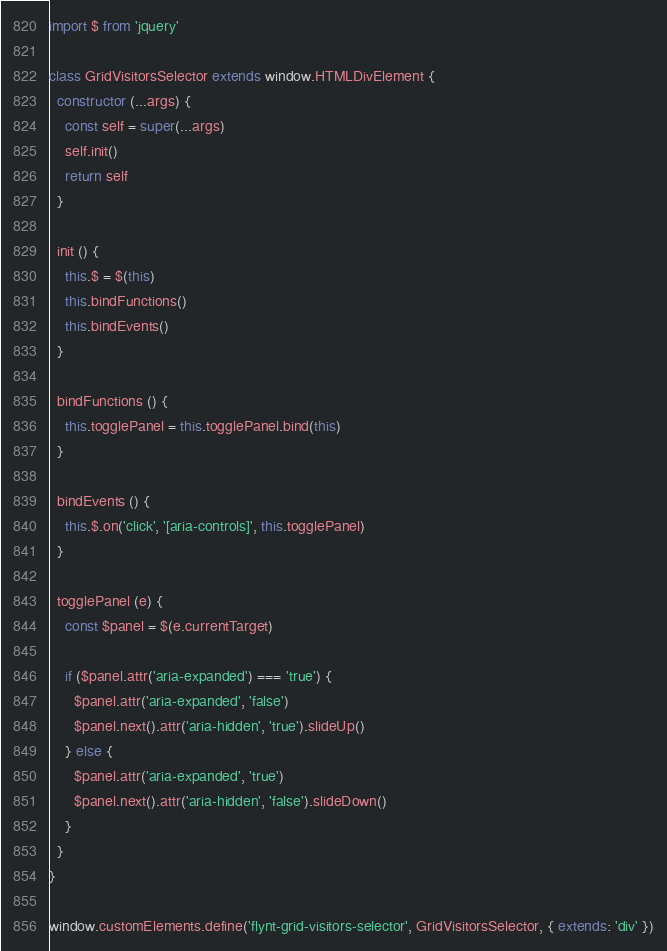Convert code to text. <code><loc_0><loc_0><loc_500><loc_500><_JavaScript_>import $ from 'jquery'

class GridVisitorsSelector extends window.HTMLDivElement {
  constructor (...args) {
    const self = super(...args)
    self.init()
    return self
  }

  init () {
    this.$ = $(this)
    this.bindFunctions()
    this.bindEvents()
  }

  bindFunctions () {
    this.togglePanel = this.togglePanel.bind(this)
  }

  bindEvents () {
    this.$.on('click', '[aria-controls]', this.togglePanel)
  }

  togglePanel (e) {
    const $panel = $(e.currentTarget)

    if ($panel.attr('aria-expanded') === 'true') {
      $panel.attr('aria-expanded', 'false')
      $panel.next().attr('aria-hidden', 'true').slideUp()
    } else {
      $panel.attr('aria-expanded', 'true')
      $panel.next().attr('aria-hidden', 'false').slideDown()
    }
  }
}

window.customElements.define('flynt-grid-visitors-selector', GridVisitorsSelector, { extends: 'div' })
</code> 